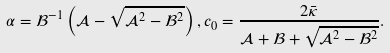<formula> <loc_0><loc_0><loc_500><loc_500>\alpha = \mathcal { B } ^ { - 1 } \left ( \mathcal { A } - \sqrt { \mathcal { A } ^ { 2 } - \mathcal { B } ^ { 2 } } \right ) , c _ { 0 } = \frac { 2 \bar { \kappa } } { \mathcal { A } + \mathcal { B } + \sqrt { \mathcal { A } ^ { 2 } - \mathcal { B } ^ { 2 } } } .</formula> 